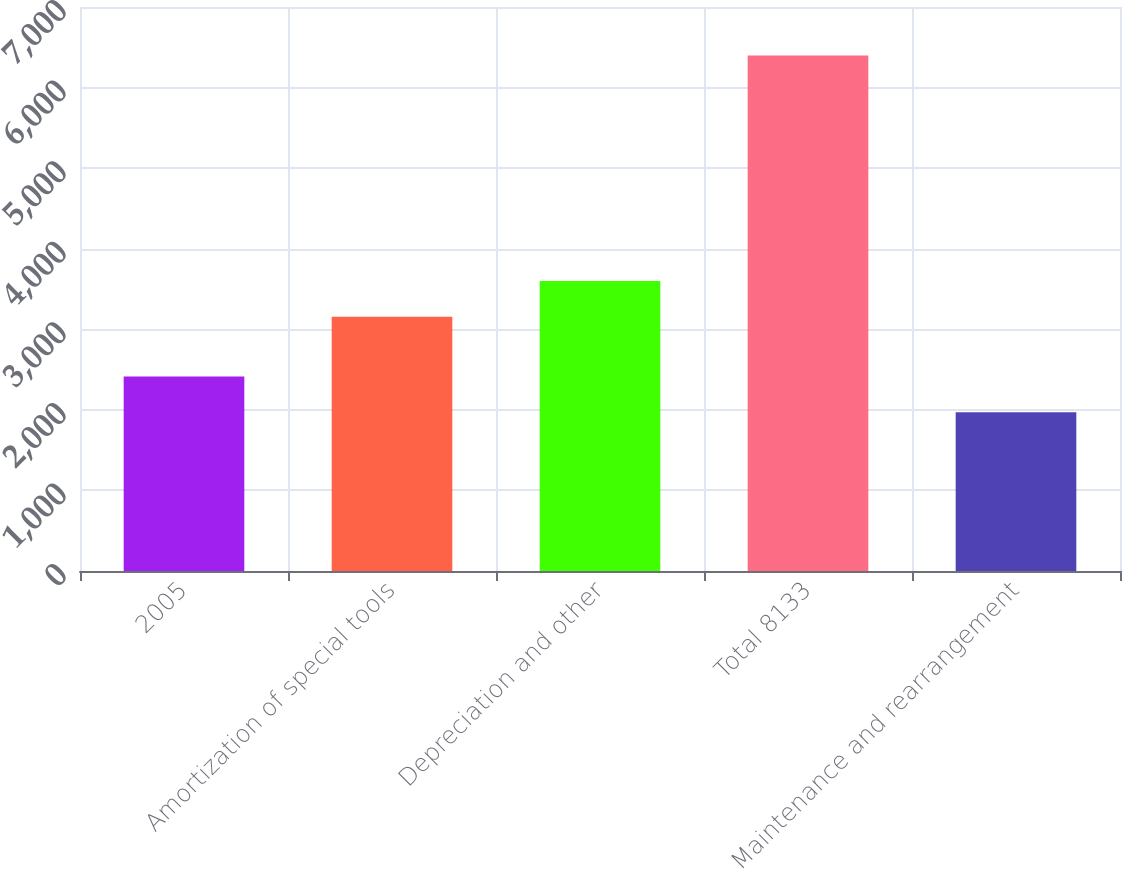Convert chart. <chart><loc_0><loc_0><loc_500><loc_500><bar_chart><fcel>2005<fcel>Amortization of special tools<fcel>Depreciation and other<fcel>Total 8133<fcel>Maintenance and rearrangement<nl><fcel>2413.6<fcel>3156<fcel>3598.6<fcel>6397<fcel>1971<nl></chart> 